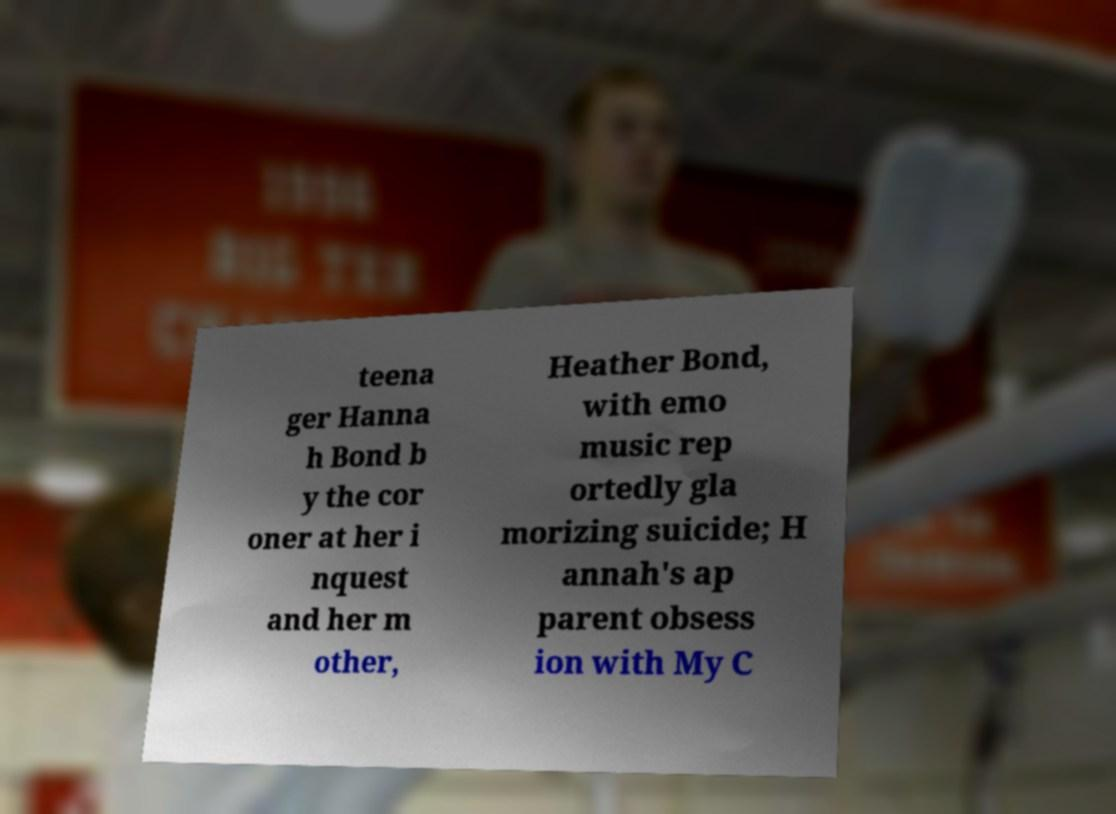There's text embedded in this image that I need extracted. Can you transcribe it verbatim? teena ger Hanna h Bond b y the cor oner at her i nquest and her m other, Heather Bond, with emo music rep ortedly gla morizing suicide; H annah's ap parent obsess ion with My C 